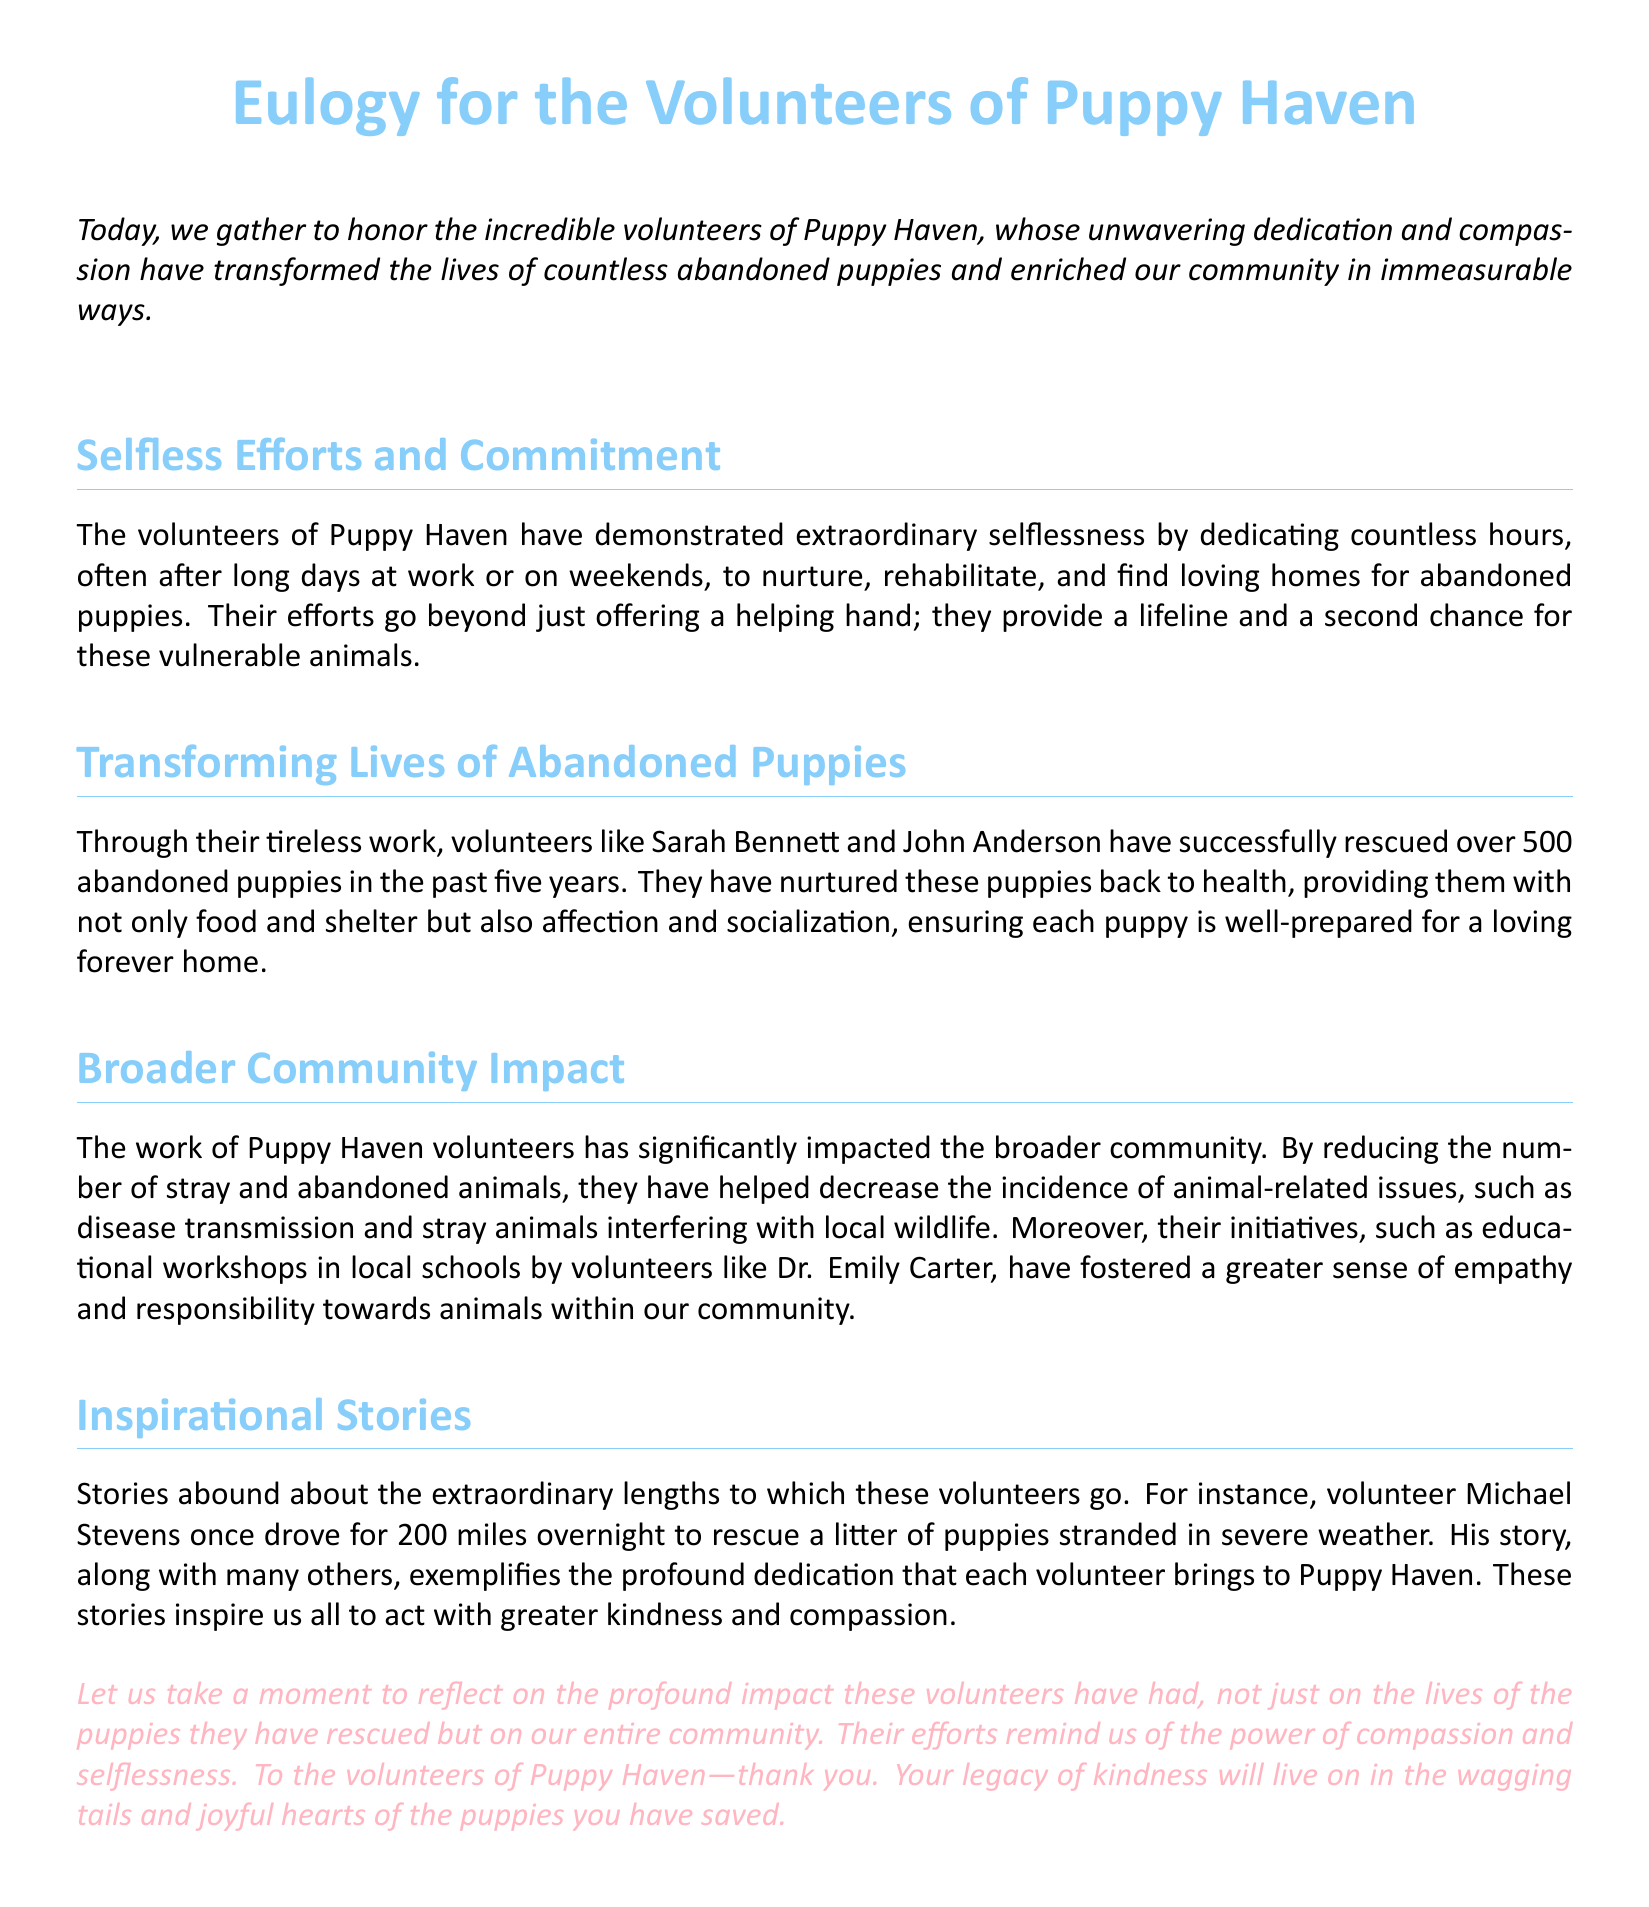what is the name of the organization being honored? The document pays tribute to the volunteers of Puppy Haven, a rescue organization.
Answer: Puppy Haven how many abandoned puppies have been rescued in the past five years? The document states that volunteers have successfully rescued over 500 abandoned puppies in the past five years.
Answer: 500 who is one of the volunteers mentioned for conducting educational workshops? Dr. Emily Carter is mentioned as a volunteer who conducts educational workshops in local schools.
Answer: Dr. Emily Carter what action did Michael Stevens take to rescue puppies? Michael Stevens drove for 200 miles overnight to rescue a litter of puppies stranded in severe weather.
Answer: 200 miles how have the efforts of Puppy Haven volunteers impacted the community? Their efforts helped reduce the number of stray and abandoned animals, thus decreasing animal-related issues within the community.
Answer: Reduced strays what theme is emphasized in the eulogy regarding the volunteers' actions? The eulogy emphasizes the themes of compassion and selflessness exhibited by the volunteers in their work with abandoned puppies.
Answer: Compassion and selflessness how long have the volunteers been working to rescue puppies? The document indicates the volunteers have been working for over five years to rescue puppies.
Answer: Over five years 